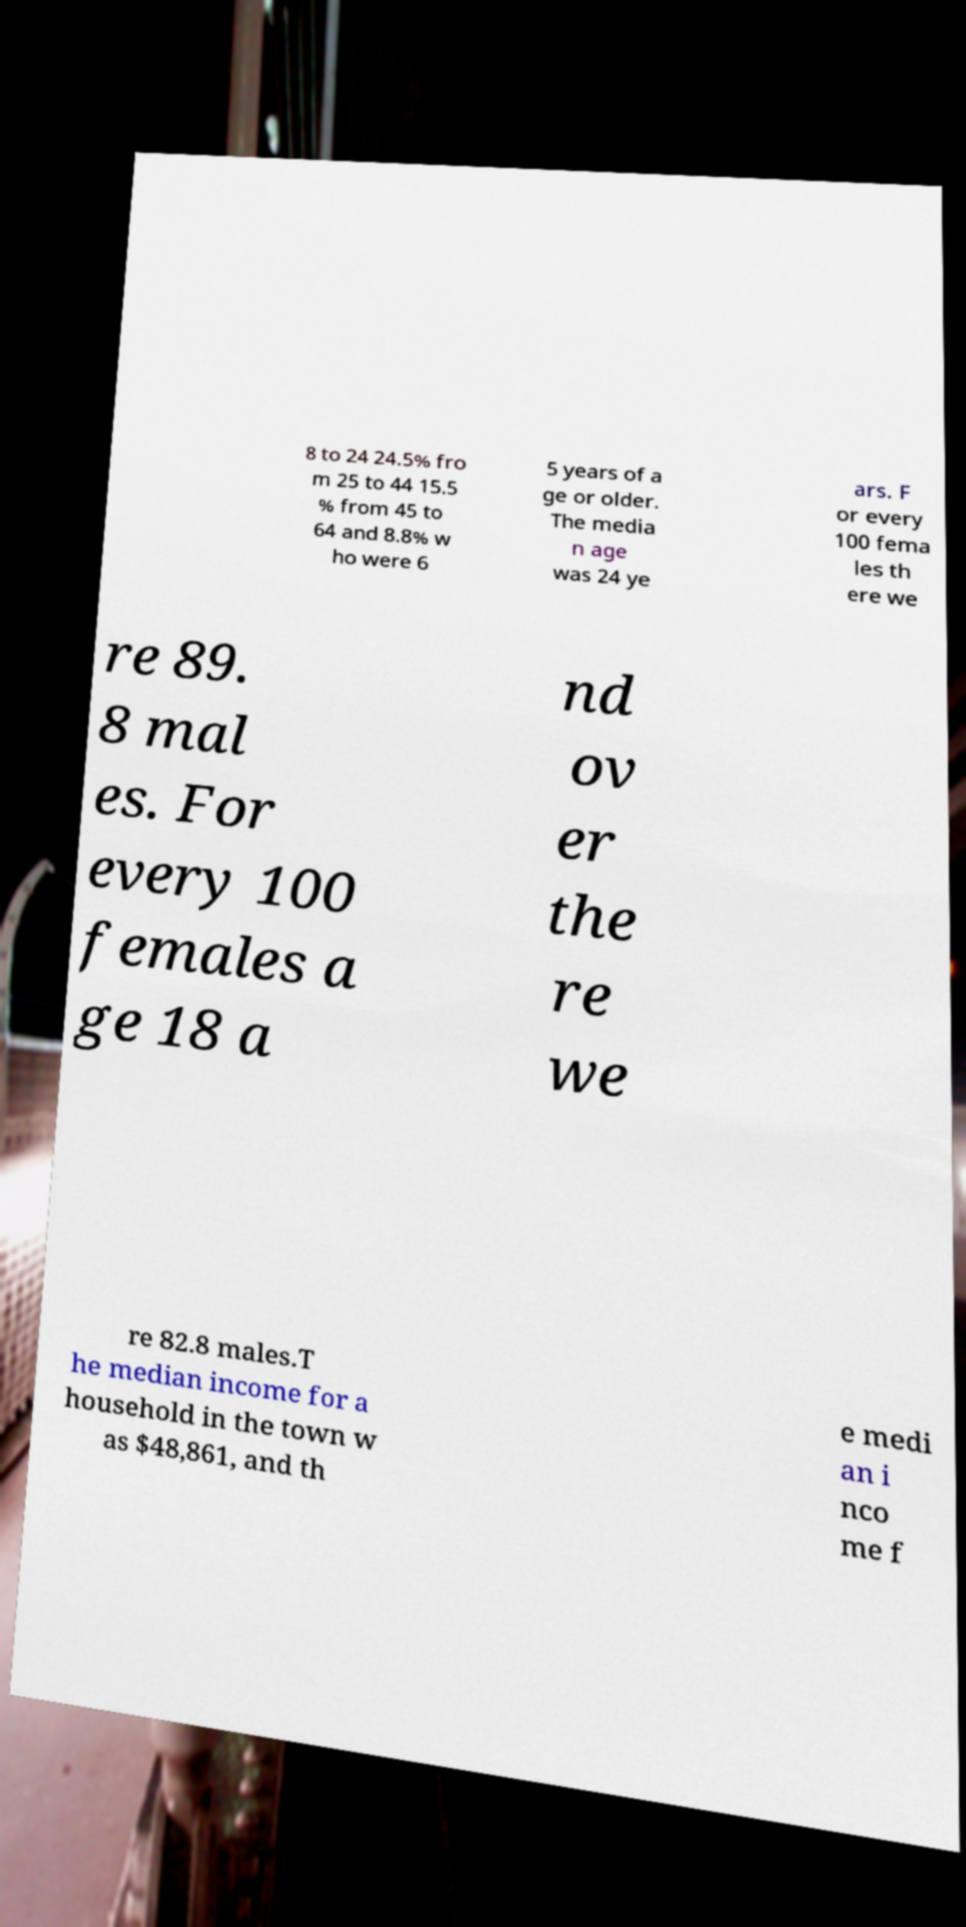I need the written content from this picture converted into text. Can you do that? 8 to 24 24.5% fro m 25 to 44 15.5 % from 45 to 64 and 8.8% w ho were 6 5 years of a ge or older. The media n age was 24 ye ars. F or every 100 fema les th ere we re 89. 8 mal es. For every 100 females a ge 18 a nd ov er the re we re 82.8 males.T he median income for a household in the town w as $48,861, and th e medi an i nco me f 